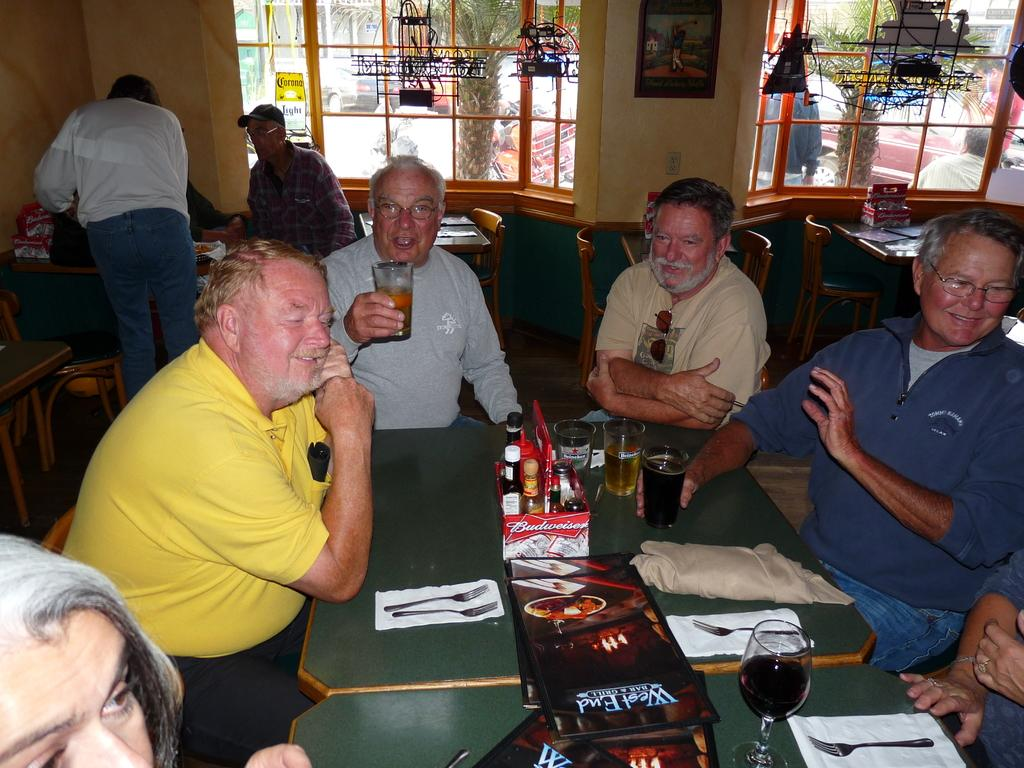How many people are in the image? There is a group of people in the image. What are the people doing in the image? The people are sitting on chairs. Where are the chairs located in relation to the table? The chairs are in front of a table. What can be seen on the table? There are objects on the table. What is visible in the background of the image? There is a window in the image. What type of space suit is the person wearing in the image? There is no person wearing a space suit in the image; the people are sitting on chairs and wearing regular clothing. 